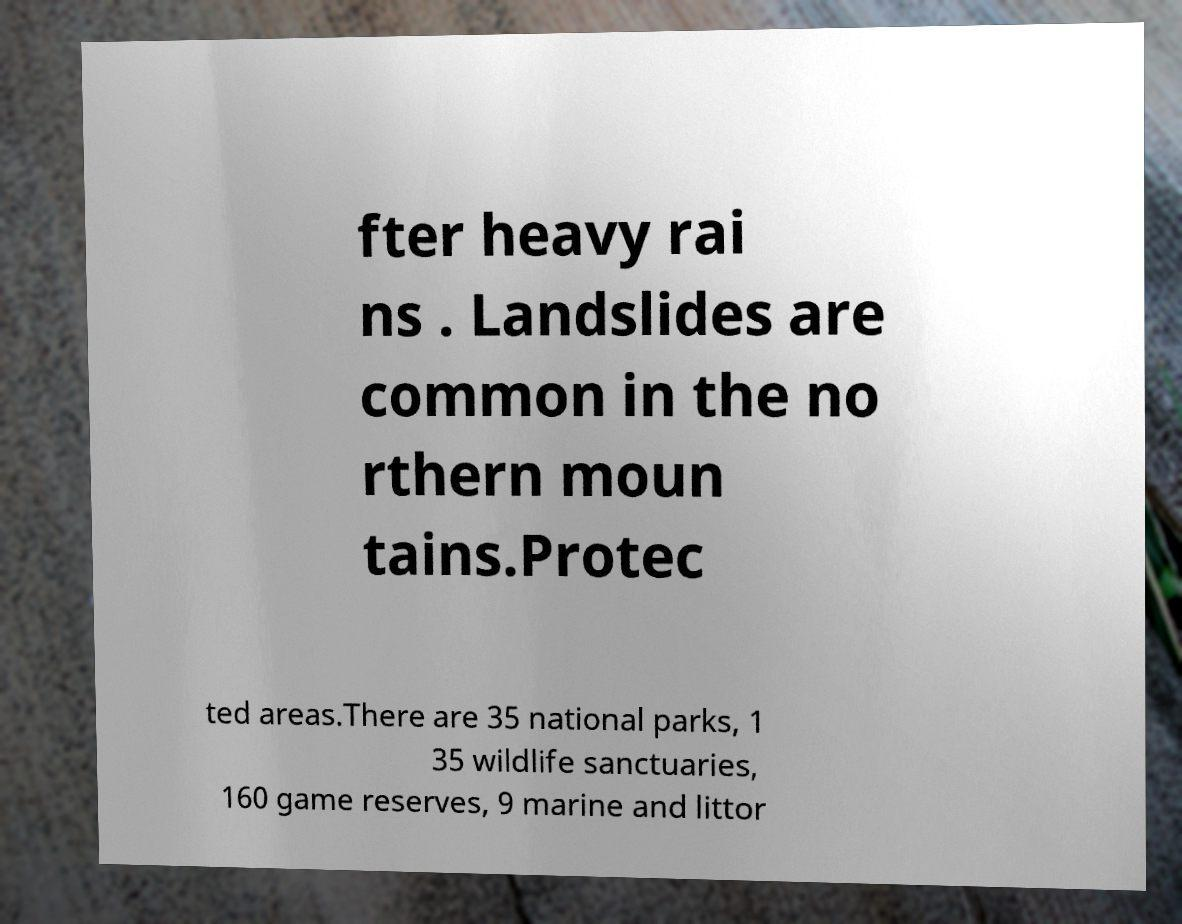There's text embedded in this image that I need extracted. Can you transcribe it verbatim? fter heavy rai ns . Landslides are common in the no rthern moun tains.Protec ted areas.There are 35 national parks, 1 35 wildlife sanctuaries, 160 game reserves, 9 marine and littor 